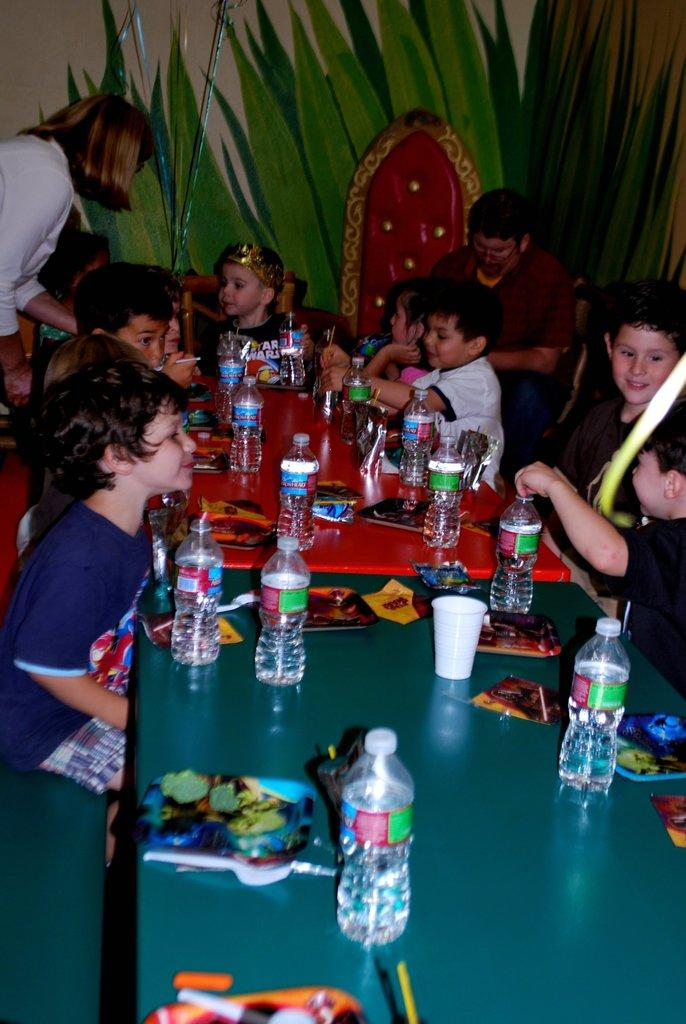Who is present in the image? There are children in the image. Where are the children located in the image? The children are gathered at a table. What are the children doing at the table? The children are having snacks. What type of event is taking place in the image? The event is a birthday party. Can you see any geese flying over the wilderness in the image? There are no geese or wilderness present in the image; it features children at a birthday party. 